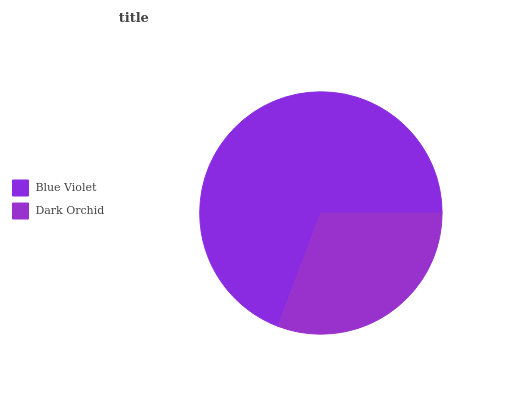Is Dark Orchid the minimum?
Answer yes or no. Yes. Is Blue Violet the maximum?
Answer yes or no. Yes. Is Dark Orchid the maximum?
Answer yes or no. No. Is Blue Violet greater than Dark Orchid?
Answer yes or no. Yes. Is Dark Orchid less than Blue Violet?
Answer yes or no. Yes. Is Dark Orchid greater than Blue Violet?
Answer yes or no. No. Is Blue Violet less than Dark Orchid?
Answer yes or no. No. Is Blue Violet the high median?
Answer yes or no. Yes. Is Dark Orchid the low median?
Answer yes or no. Yes. Is Dark Orchid the high median?
Answer yes or no. No. Is Blue Violet the low median?
Answer yes or no. No. 